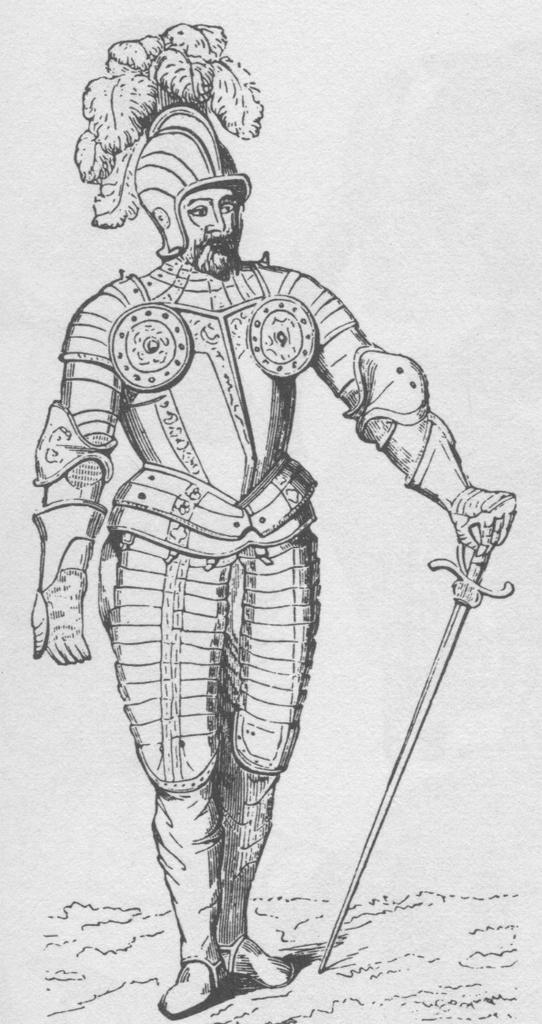What is the main subject of the painting in the image? The painting depicts a man. What is the man wearing in the painting? The man is wearing a helmet and armor in the painting. What is the man holding in the painting? The man is holding a sword in the painting. How many keys can be seen hanging from the man's belt in the painting? There are no keys visible in the painting; the man is holding a sword and wearing a helmet and armor. What type of kite is the man flying in the painting? There is no kite present in the painting; the man is depicted with a sword, helmet, and armor. 